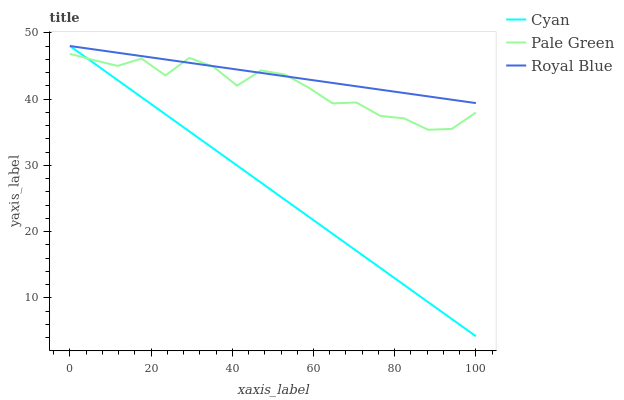Does Cyan have the minimum area under the curve?
Answer yes or no. Yes. Does Royal Blue have the maximum area under the curve?
Answer yes or no. Yes. Does Pale Green have the minimum area under the curve?
Answer yes or no. No. Does Pale Green have the maximum area under the curve?
Answer yes or no. No. Is Cyan the smoothest?
Answer yes or no. Yes. Is Pale Green the roughest?
Answer yes or no. Yes. Is Royal Blue the smoothest?
Answer yes or no. No. Is Royal Blue the roughest?
Answer yes or no. No. Does Cyan have the lowest value?
Answer yes or no. Yes. Does Pale Green have the lowest value?
Answer yes or no. No. Does Royal Blue have the highest value?
Answer yes or no. Yes. Does Pale Green have the highest value?
Answer yes or no. No. Does Cyan intersect Pale Green?
Answer yes or no. Yes. Is Cyan less than Pale Green?
Answer yes or no. No. Is Cyan greater than Pale Green?
Answer yes or no. No. 